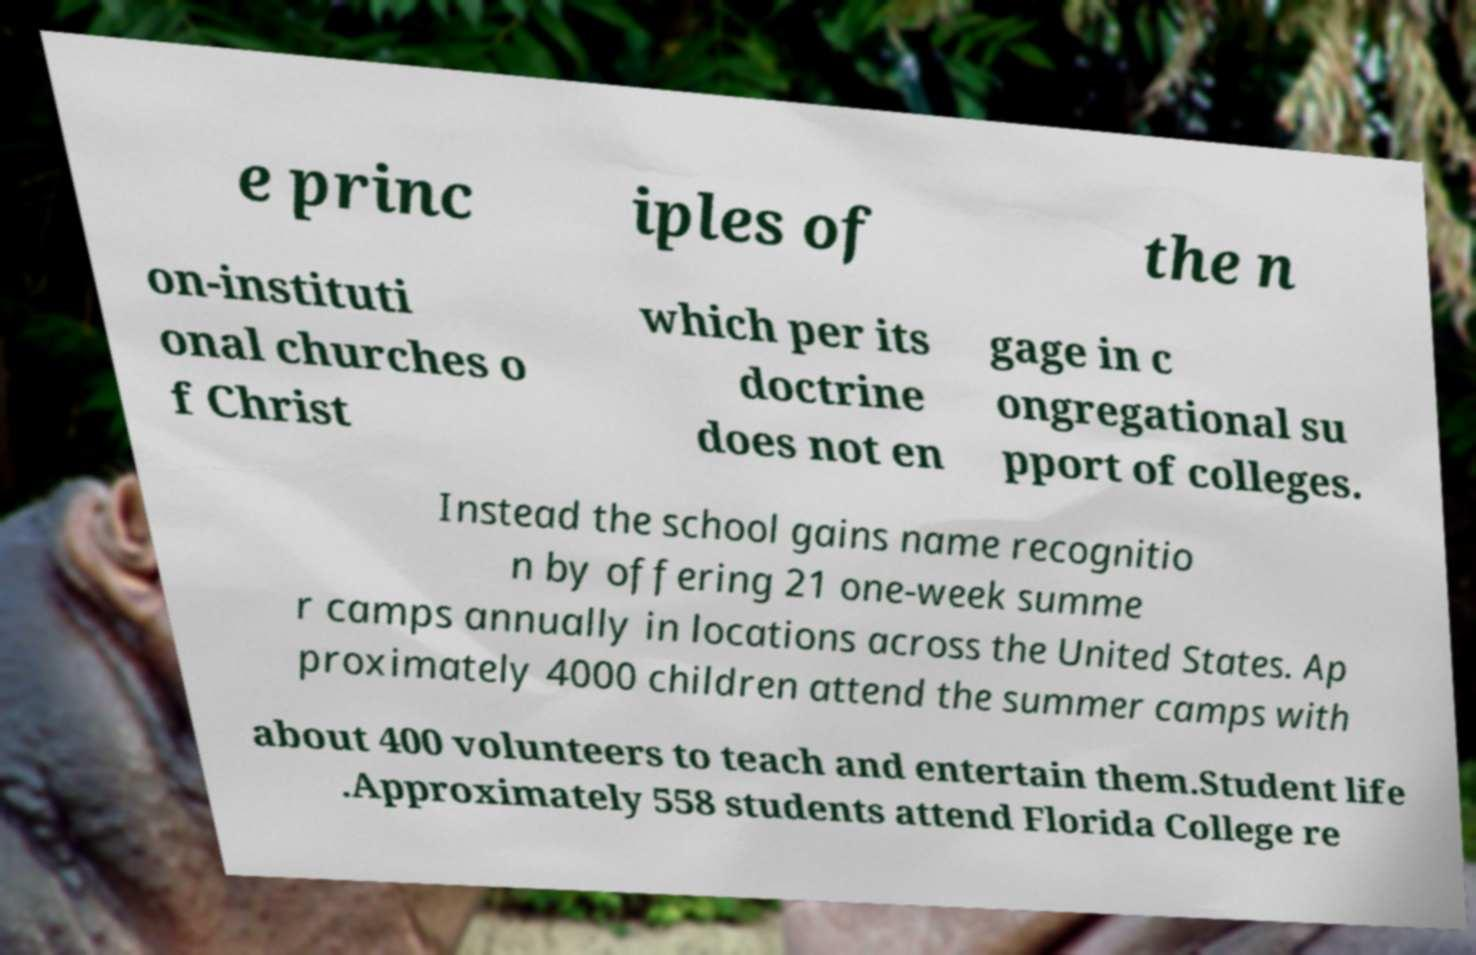There's text embedded in this image that I need extracted. Can you transcribe it verbatim? e princ iples of the n on-instituti onal churches o f Christ which per its doctrine does not en gage in c ongregational su pport of colleges. Instead the school gains name recognitio n by offering 21 one-week summe r camps annually in locations across the United States. Ap proximately 4000 children attend the summer camps with about 400 volunteers to teach and entertain them.Student life .Approximately 558 students attend Florida College re 